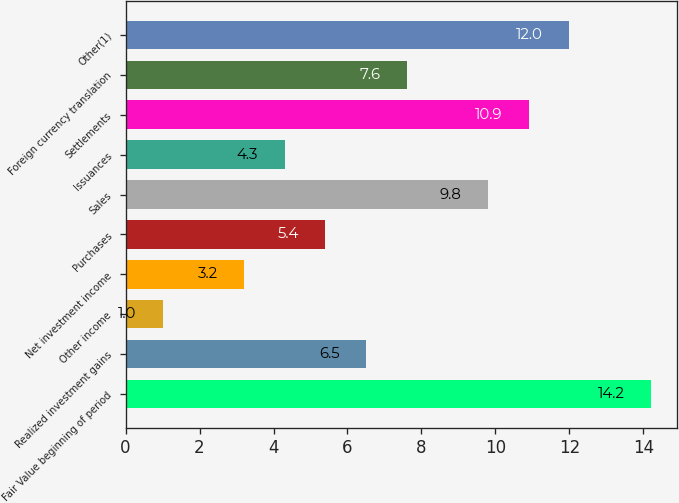Convert chart. <chart><loc_0><loc_0><loc_500><loc_500><bar_chart><fcel>Fair Value beginning of period<fcel>Realized investment gains<fcel>Other income<fcel>Net investment income<fcel>Purchases<fcel>Sales<fcel>Issuances<fcel>Settlements<fcel>Foreign currency translation<fcel>Other(1)<nl><fcel>14.2<fcel>6.5<fcel>1<fcel>3.2<fcel>5.4<fcel>9.8<fcel>4.3<fcel>10.9<fcel>7.6<fcel>12<nl></chart> 